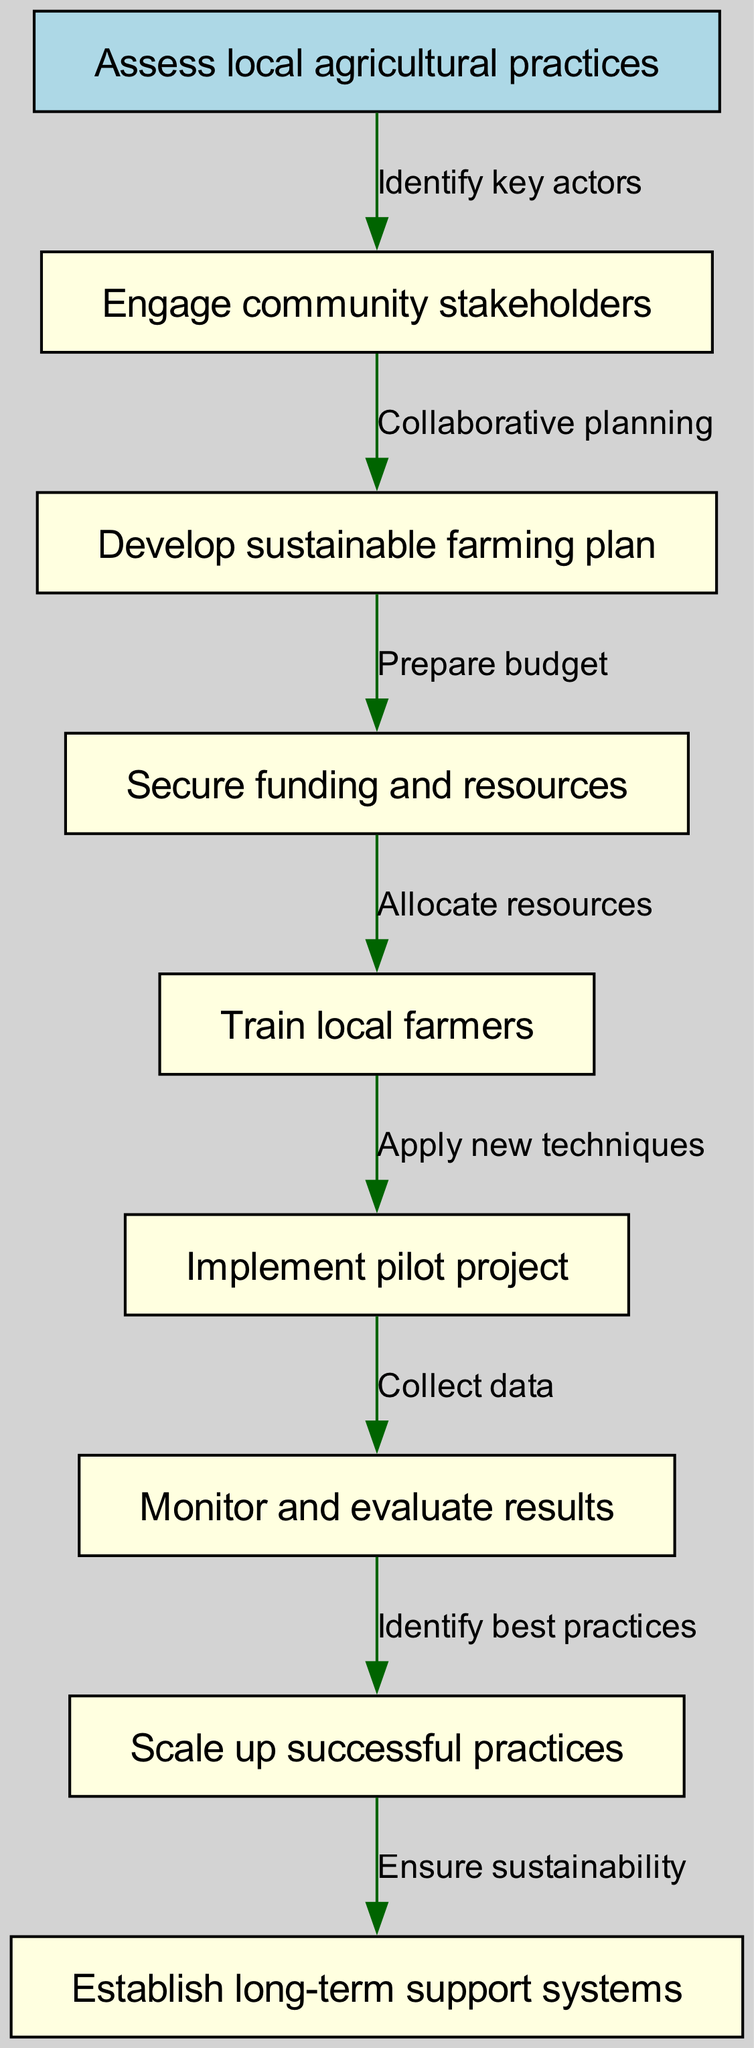What is the start node of the diagram? The start node is explicitly stated as "Assess local agricultural practices." This is the initial point in the flow chart where the process begins.
Answer: Assess local agricultural practices How many nodes are in the diagram? The diagram contains a total of 8 nodes, including the start node. This was counted by listing all nodes presented in the data provided.
Answer: 8 Which node follows "Engage community stakeholders"? The diagram shows that after engaging community stakeholders, the next step is to "Develop sustainable farming plan." This is a direct relationship indicated by the flow of the chart.
Answer: Develop sustainable farming plan What is the relationship between "Train local farmers" and "Implement pilot project"? According to the diagram, the relationship is established as "Apply new techniques." This labels the edge connecting these two nodes and describes the action taken.
Answer: Apply new techniques What is the final node of the diagram? The last node in the flow chart is "Establish long-term support systems." This signifies the end of the implementation stages listed in the diagram.
Answer: Establish long-term support systems What does "Monitor and evaluate results" lead to? In the flow of the diagram, "Monitor and evaluate results" leads to "Scale up successful practices." This indicates what is done after the monitoring phase is completed.
Answer: Scale up successful practices What step comes after securing funding and resources? After "Secure funding and resources," the next step is "Train local farmers." This indicates how resources are utilized in the subsequent action.
Answer: Train local farmers How many edges are in the diagram? The diagram includes 7 edges that illustrate the connections and transitions between the different nodes. Each edge represents one connection flowing from one node to another.
Answer: 7 What aspect does "Collect data" pertain to? "Collect data" pertains to "Monitor and evaluate results." This step emphasizes the need for data collection to assess the outcomes of the pilot project.
Answer: Monitor and evaluate results 